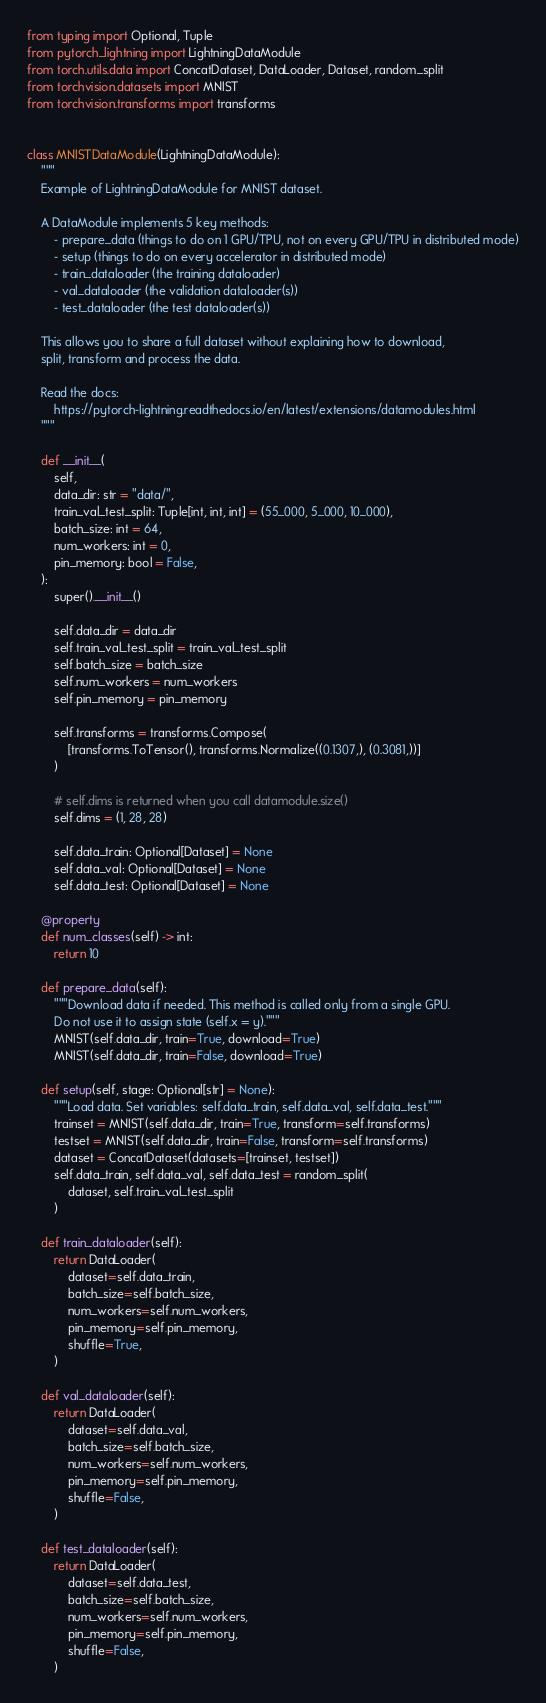Convert code to text. <code><loc_0><loc_0><loc_500><loc_500><_Python_>from typing import Optional, Tuple
from pytorch_lightning import LightningDataModule
from torch.utils.data import ConcatDataset, DataLoader, Dataset, random_split
from torchvision.datasets import MNIST
from torchvision.transforms import transforms


class MNISTDataModule(LightningDataModule):
    """
    Example of LightningDataModule for MNIST dataset.

    A DataModule implements 5 key methods:
        - prepare_data (things to do on 1 GPU/TPU, not on every GPU/TPU in distributed mode)
        - setup (things to do on every accelerator in distributed mode)
        - train_dataloader (the training dataloader)
        - val_dataloader (the validation dataloader(s))
        - test_dataloader (the test dataloader(s))

    This allows you to share a full dataset without explaining how to download,
    split, transform and process the data.

    Read the docs:
        https://pytorch-lightning.readthedocs.io/en/latest/extensions/datamodules.html
    """

    def __init__(
        self,
        data_dir: str = "data/",
        train_val_test_split: Tuple[int, int, int] = (55_000, 5_000, 10_000),
        batch_size: int = 64,
        num_workers: int = 0,
        pin_memory: bool = False,
    ):
        super().__init__()

        self.data_dir = data_dir
        self.train_val_test_split = train_val_test_split
        self.batch_size = batch_size
        self.num_workers = num_workers
        self.pin_memory = pin_memory

        self.transforms = transforms.Compose(
            [transforms.ToTensor(), transforms.Normalize((0.1307,), (0.3081,))]
        )

        # self.dims is returned when you call datamodule.size()
        self.dims = (1, 28, 28)

        self.data_train: Optional[Dataset] = None
        self.data_val: Optional[Dataset] = None
        self.data_test: Optional[Dataset] = None

    @property
    def num_classes(self) -> int:
        return 10

    def prepare_data(self):
        """Download data if needed. This method is called only from a single GPU.
        Do not use it to assign state (self.x = y)."""
        MNIST(self.data_dir, train=True, download=True)
        MNIST(self.data_dir, train=False, download=True)

    def setup(self, stage: Optional[str] = None):
        """Load data. Set variables: self.data_train, self.data_val, self.data_test."""
        trainset = MNIST(self.data_dir, train=True, transform=self.transforms)
        testset = MNIST(self.data_dir, train=False, transform=self.transforms)
        dataset = ConcatDataset(datasets=[trainset, testset])
        self.data_train, self.data_val, self.data_test = random_split(
            dataset, self.train_val_test_split
        )

    def train_dataloader(self):
        return DataLoader(
            dataset=self.data_train,
            batch_size=self.batch_size,
            num_workers=self.num_workers,
            pin_memory=self.pin_memory,
            shuffle=True,
        )

    def val_dataloader(self):
        return DataLoader(
            dataset=self.data_val,
            batch_size=self.batch_size,
            num_workers=self.num_workers,
            pin_memory=self.pin_memory,
            shuffle=False,
        )

    def test_dataloader(self):
        return DataLoader(
            dataset=self.data_test,
            batch_size=self.batch_size,
            num_workers=self.num_workers,
            pin_memory=self.pin_memory,
            shuffle=False,
        )
</code> 